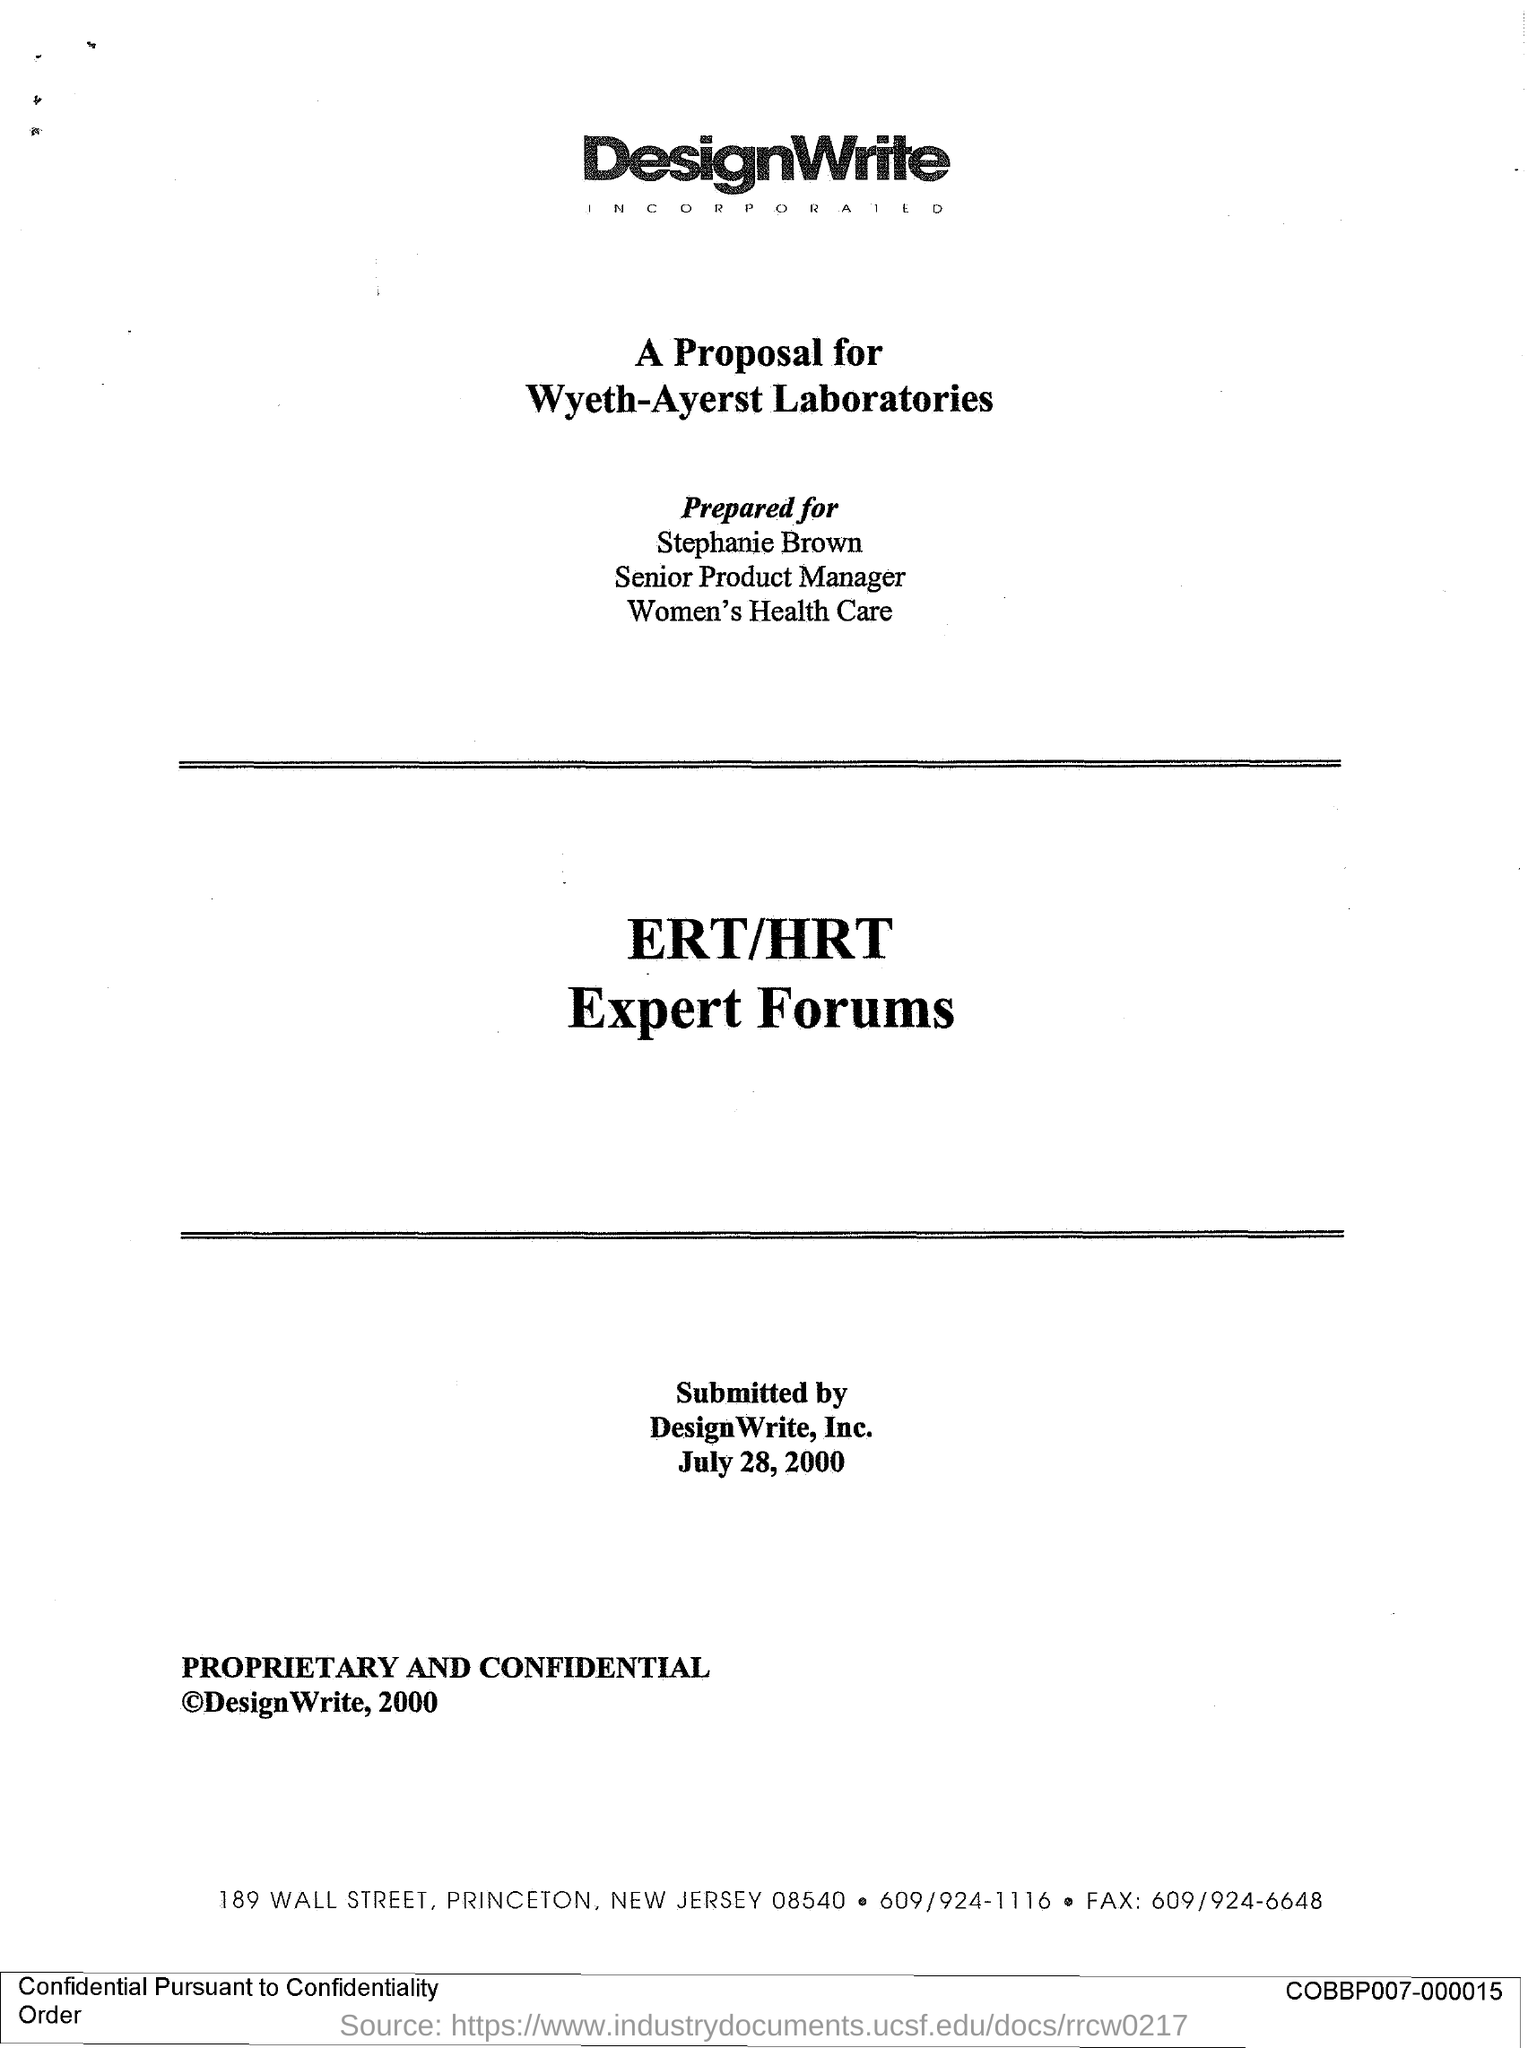Point out several critical features in this image. The fax number provided is 609/924-6648. The proposal was submitted by DesignWrite, Inc. The proposal was submitted on July 28, 2000. The proposed plan is to establish ERT/HRT Expert Forums, which will serve as a platform for experts to discuss and provide guidance on issues related to the European Recovery Team (ERT) and the Hosting Recovery Team (HRT). Stephanie Brown is a Senior Product Manager with a title that has not yet been determined. 